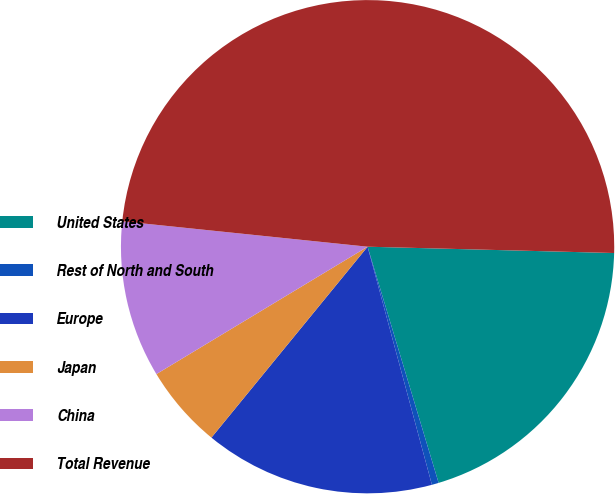Convert chart. <chart><loc_0><loc_0><loc_500><loc_500><pie_chart><fcel>United States<fcel>Rest of North and South<fcel>Europe<fcel>Japan<fcel>China<fcel>Total Revenue<nl><fcel>19.94%<fcel>0.45%<fcel>15.11%<fcel>5.45%<fcel>10.28%<fcel>48.76%<nl></chart> 